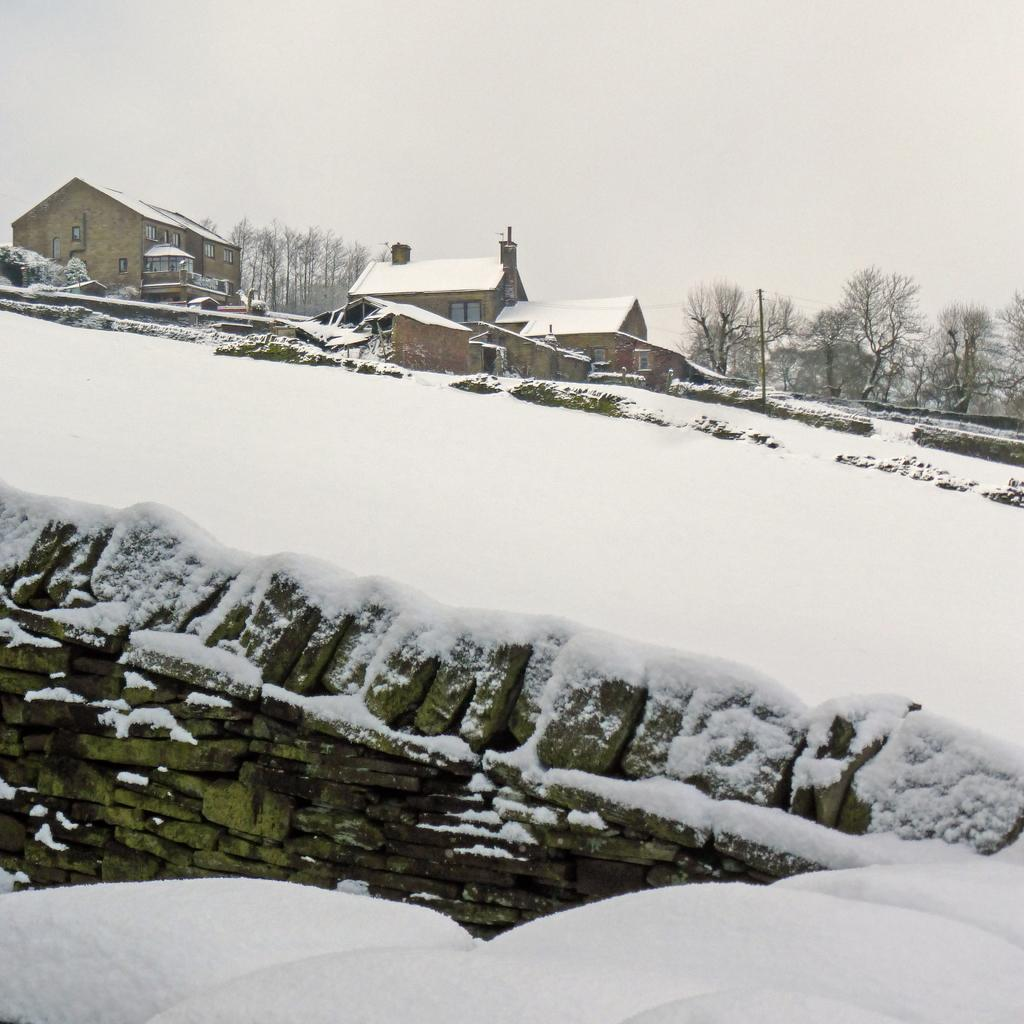What is covering the wall at the bottom of the image? There is a wall covered with snow at the bottom of the image. What can be seen in the background of the image? There are houses and trees in the background of the image. What is visible at the top of the image? The sky is visible at the top of the image. Can you see a cat making a wish in the image? There is no cat or wishing activity present in the image. 